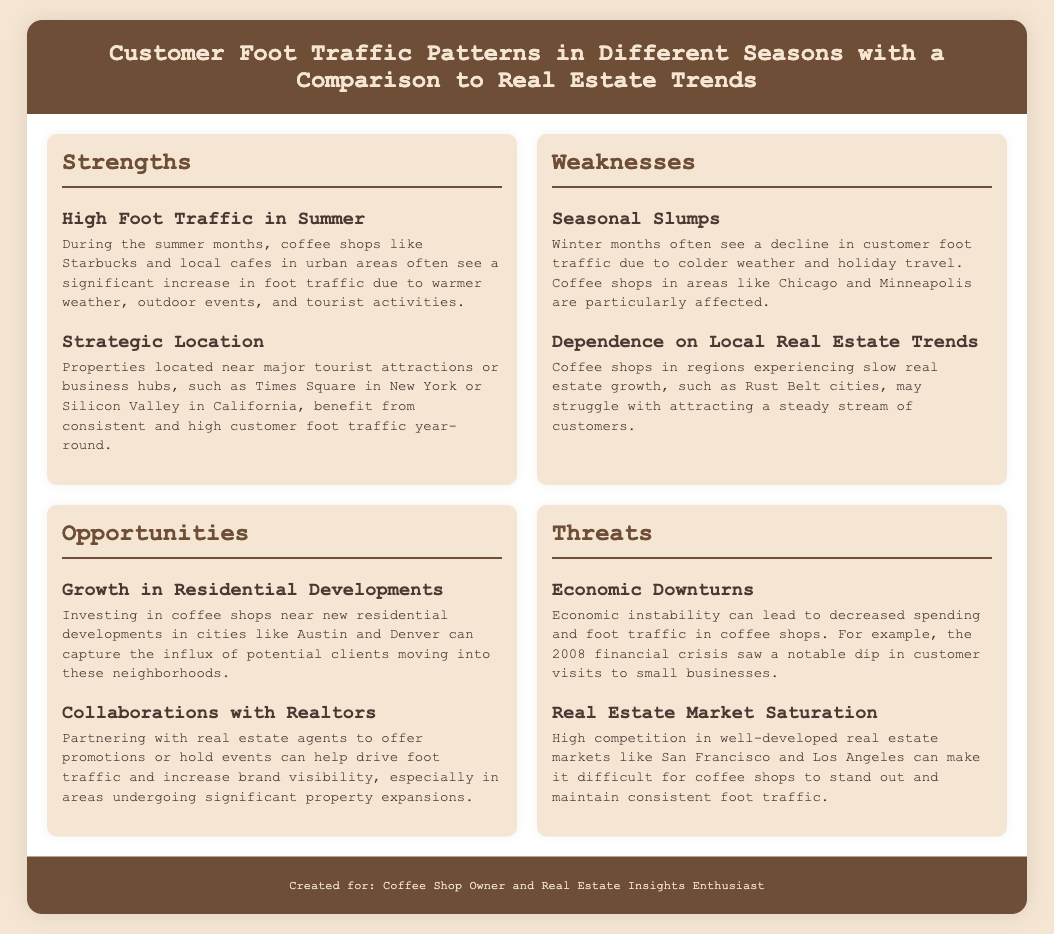What is a major strength for coffee shops in summer? The document states that during the summer months, coffee shops see a significant increase in foot traffic due to warmer weather.
Answer: High Foot Traffic in Summer What is one weakness related to seasonal changes? The document mentions that winter months often see a decline in customer foot traffic due to colder weather.
Answer: Seasonal Slumps What opportunity is presented by residential developments? The document highlights the potential for coffee shops to capture clients moving into new neighborhoods due to growth in residential areas.
Answer: Growth in Residential Developments What threat is mentioned concerning the economy? The document indicates that economic instability can lead to decreased spending and foot traffic in coffee shops.
Answer: Economic Downturns Which location is cited as having strategic advantage for coffee shops? The document references properties located near major tourist attractions as benefiting from consistent high foot traffic.
Answer: Major tourist attractions How do seasonal foot traffic patterns relate to real estate trends? The document indicates that coffee shops in areas experiencing slow real estate growth may struggle with attracting customers.
Answer: Dependence on Local Real Estate Trends What type of business collaboration is mentioned as an opportunity? The document suggests partnering with real estate agents to increase brand visibility and drive foot traffic as an opportunity.
Answer: Collaborations with Realtors 